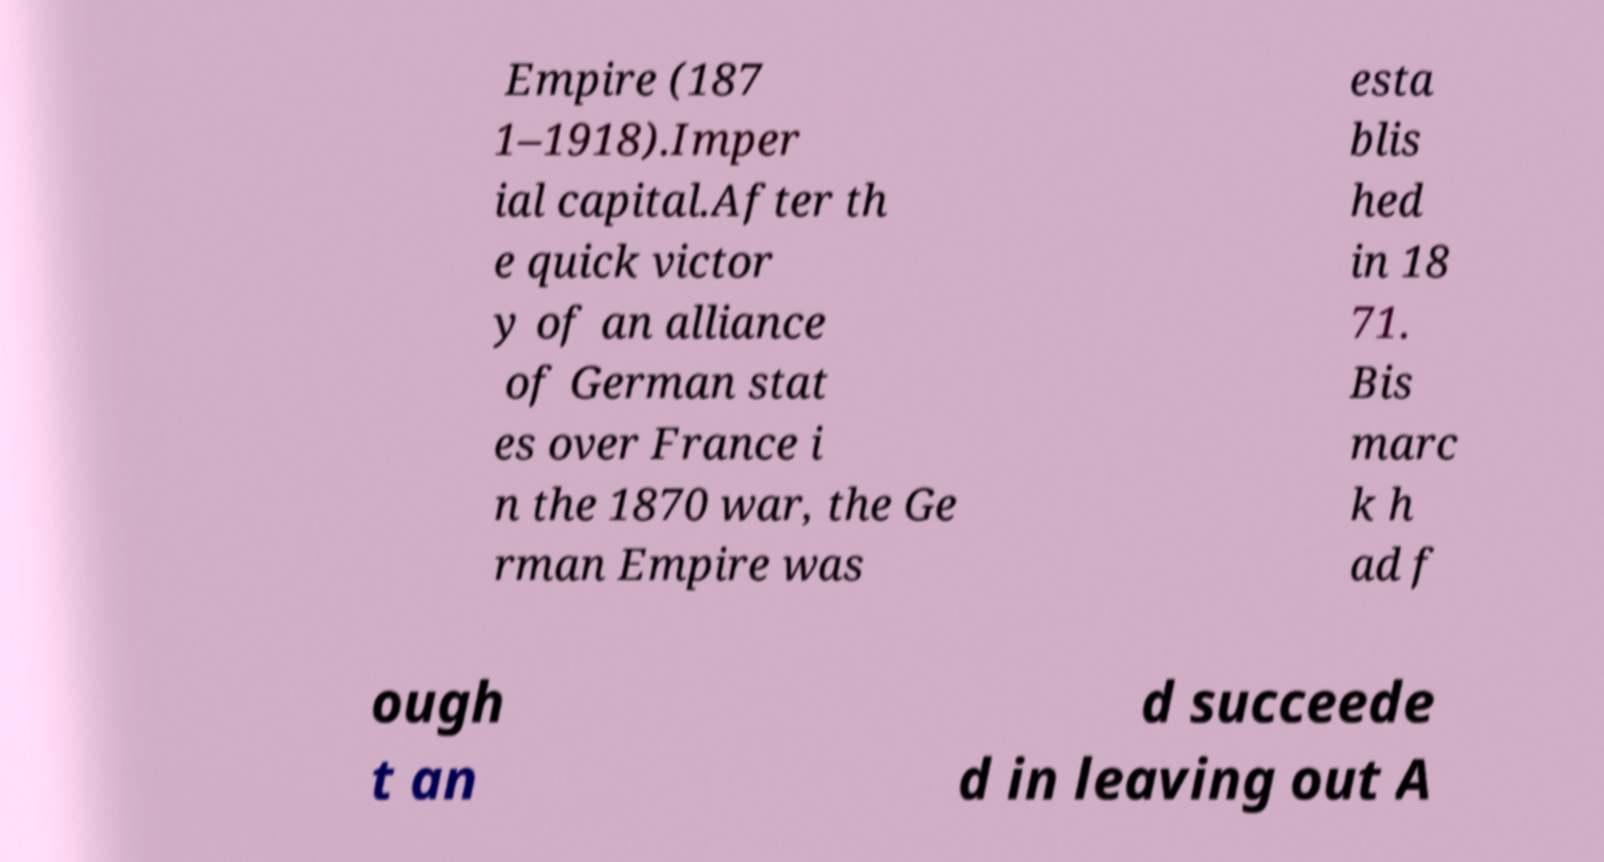I need the written content from this picture converted into text. Can you do that? Empire (187 1–1918).Imper ial capital.After th e quick victor y of an alliance of German stat es over France i n the 1870 war, the Ge rman Empire was esta blis hed in 18 71. Bis marc k h ad f ough t an d succeede d in leaving out A 